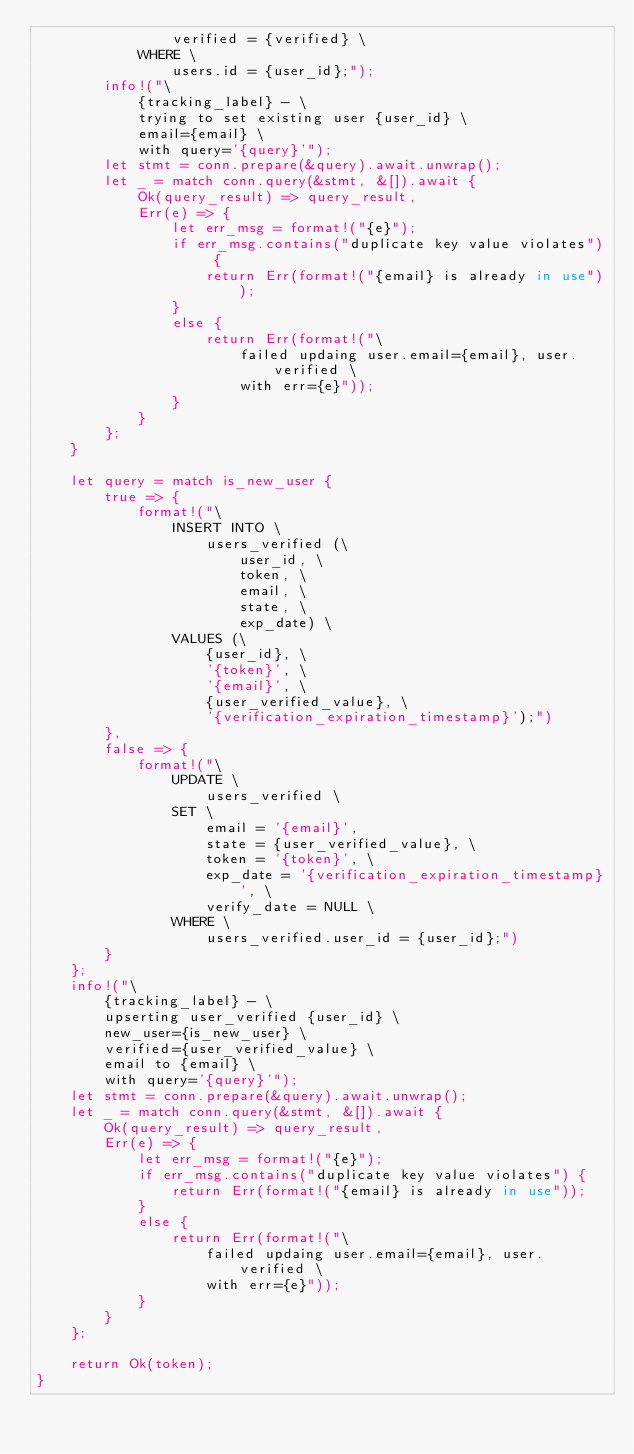Convert code to text. <code><loc_0><loc_0><loc_500><loc_500><_Rust_>                verified = {verified} \
            WHERE \
                users.id = {user_id};");
        info!("\
            {tracking_label} - \
            trying to set existing user {user_id} \
            email={email} \
            with query='{query}'");
        let stmt = conn.prepare(&query).await.unwrap();
        let _ = match conn.query(&stmt, &[]).await {
            Ok(query_result) => query_result,
            Err(e) => {
                let err_msg = format!("{e}");
                if err_msg.contains("duplicate key value violates") {
                    return Err(format!("{email} is already in use"));
                }
                else {
                    return Err(format!("\
                        failed updaing user.email={email}, user.verified \
                        with err={e}"));
                }
            }
        };
    }

    let query = match is_new_user {
        true => {
            format!("\
                INSERT INTO \
                    users_verified (\
                        user_id, \
                        token, \
                        email, \
                        state, \
                        exp_date) \
                VALUES (\
                    {user_id}, \
                    '{token}', \
                    '{email}', \
                    {user_verified_value}, \
                    '{verification_expiration_timestamp}');")
        },
        false => {
            format!("\
                UPDATE \
                    users_verified \
                SET \
                    email = '{email}',
                    state = {user_verified_value}, \
                    token = '{token}', \
                    exp_date = '{verification_expiration_timestamp}', \
                    verify_date = NULL \
                WHERE \
                    users_verified.user_id = {user_id};")
        }
    };
    info!("\
        {tracking_label} - \
        upserting user_verified {user_id} \
        new_user={is_new_user} \
        verified={user_verified_value} \
        email to {email} \
        with query='{query}'");
    let stmt = conn.prepare(&query).await.unwrap();
    let _ = match conn.query(&stmt, &[]).await {
        Ok(query_result) => query_result,
        Err(e) => {
            let err_msg = format!("{e}");
            if err_msg.contains("duplicate key value violates") {
                return Err(format!("{email} is already in use"));
            }
            else {
                return Err(format!("\
                    failed updaing user.email={email}, user.verified \
                    with err={e}"));
            }
        }
    };

    return Ok(token);
}
</code> 